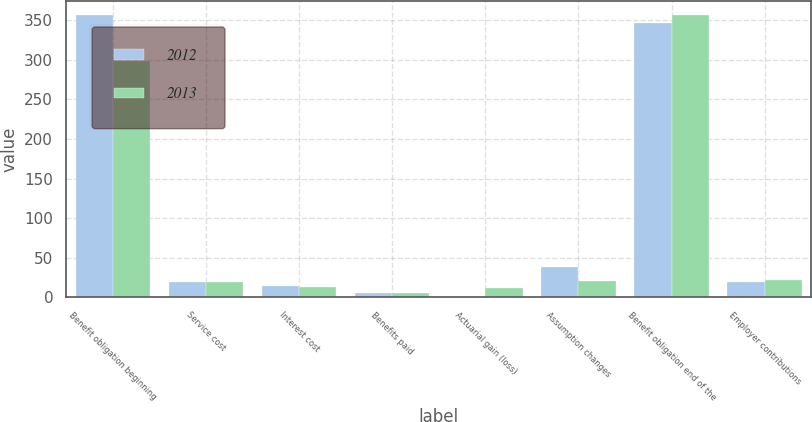<chart> <loc_0><loc_0><loc_500><loc_500><stacked_bar_chart><ecel><fcel>Benefit obligation beginning<fcel>Service cost<fcel>Interest cost<fcel>Benefits paid<fcel>Actuarial gain (loss)<fcel>Assumption changes<fcel>Benefit obligation end of the<fcel>Employer contributions<nl><fcel>2012<fcel>356.3<fcel>19.8<fcel>13.5<fcel>5.3<fcel>0.7<fcel>37.9<fcel>347.1<fcel>19.3<nl><fcel>2013<fcel>298.8<fcel>18.9<fcel>13.1<fcel>5.7<fcel>11<fcel>20.2<fcel>356.3<fcel>21.3<nl></chart> 